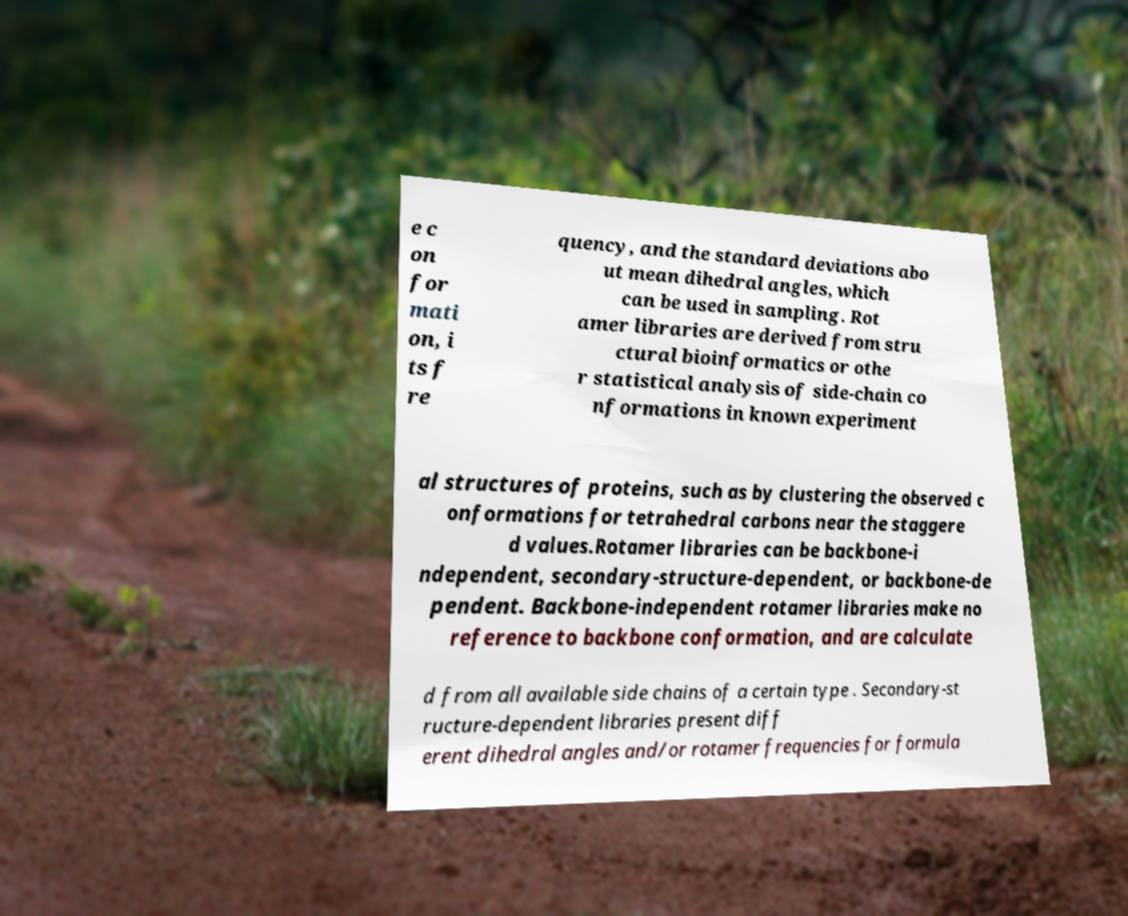For documentation purposes, I need the text within this image transcribed. Could you provide that? e c on for mati on, i ts f re quency, and the standard deviations abo ut mean dihedral angles, which can be used in sampling. Rot amer libraries are derived from stru ctural bioinformatics or othe r statistical analysis of side-chain co nformations in known experiment al structures of proteins, such as by clustering the observed c onformations for tetrahedral carbons near the staggere d values.Rotamer libraries can be backbone-i ndependent, secondary-structure-dependent, or backbone-de pendent. Backbone-independent rotamer libraries make no reference to backbone conformation, and are calculate d from all available side chains of a certain type . Secondary-st ructure-dependent libraries present diff erent dihedral angles and/or rotamer frequencies for formula 